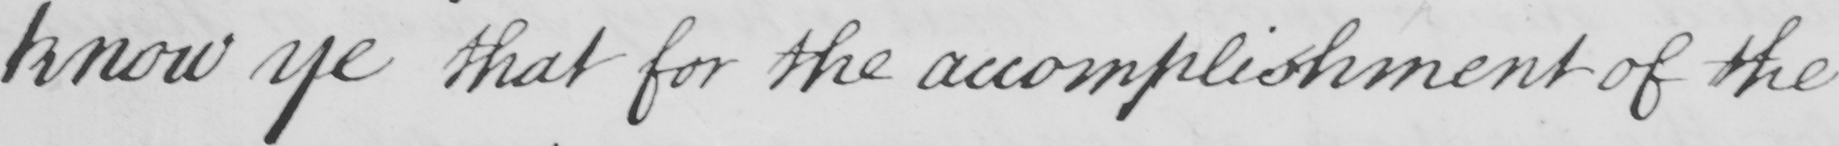Transcribe the text shown in this historical manuscript line. know ye that for the accomplishment of the 